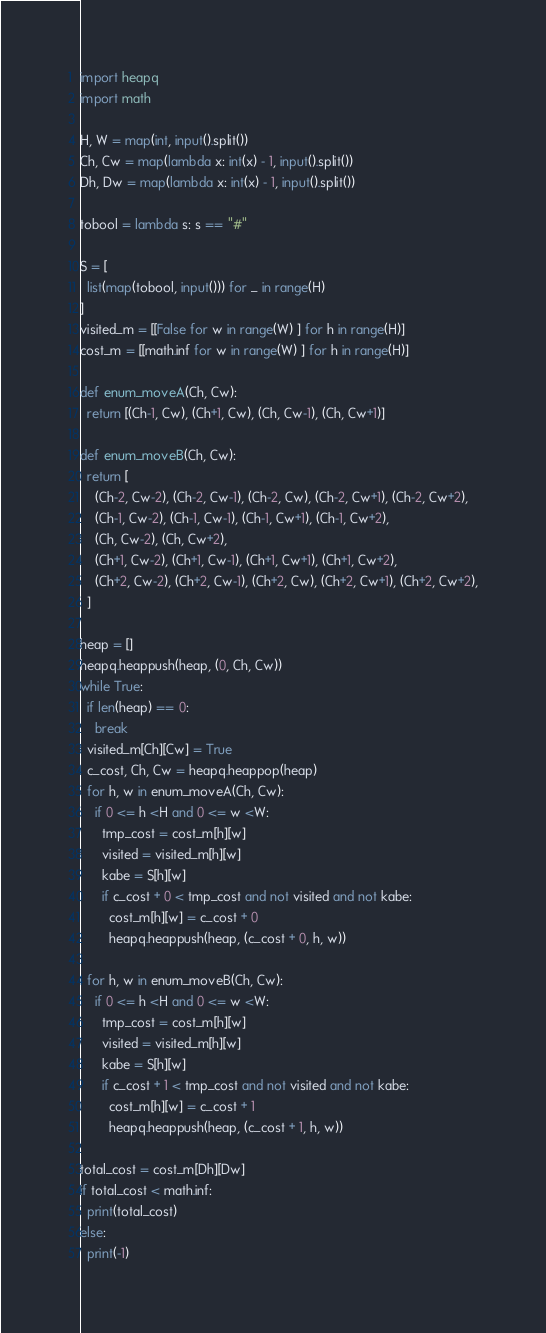<code> <loc_0><loc_0><loc_500><loc_500><_Python_>import heapq
import math

H, W = map(int, input().split())
Ch, Cw = map(lambda x: int(x) - 1, input().split())
Dh, Dw = map(lambda x: int(x) - 1, input().split())

tobool = lambda s: s == "#"

S = [
  list(map(tobool, input())) for _ in range(H)
]
visited_m = [[False for w in range(W) ] for h in range(H)]
cost_m = [[math.inf for w in range(W) ] for h in range(H)]

def enum_moveA(Ch, Cw):
  return [(Ch-1, Cw), (Ch+1, Cw), (Ch, Cw-1), (Ch, Cw+1)]

def enum_moveB(Ch, Cw):
  return [
    (Ch-2, Cw-2), (Ch-2, Cw-1), (Ch-2, Cw), (Ch-2, Cw+1), (Ch-2, Cw+2),
    (Ch-1, Cw-2), (Ch-1, Cw-1), (Ch-1, Cw+1), (Ch-1, Cw+2),
    (Ch, Cw-2), (Ch, Cw+2),
    (Ch+1, Cw-2), (Ch+1, Cw-1), (Ch+1, Cw+1), (Ch+1, Cw+2),
    (Ch+2, Cw-2), (Ch+2, Cw-1), (Ch+2, Cw), (Ch+2, Cw+1), (Ch+2, Cw+2),
  ]

heap = []
heapq.heappush(heap, (0, Ch, Cw))
while True:
  if len(heap) == 0:
    break
  visited_m[Ch][Cw] = True
  c_cost, Ch, Cw = heapq.heappop(heap)
  for h, w in enum_moveA(Ch, Cw):
    if 0 <= h <H and 0 <= w <W:
      tmp_cost = cost_m[h][w]
      visited = visited_m[h][w]
      kabe = S[h][w]
      if c_cost + 0 < tmp_cost and not visited and not kabe:
        cost_m[h][w] = c_cost + 0
        heapq.heappush(heap, (c_cost + 0, h, w))
        
  for h, w in enum_moveB(Ch, Cw):
    if 0 <= h <H and 0 <= w <W:
      tmp_cost = cost_m[h][w]
      visited = visited_m[h][w]
      kabe = S[h][w]
      if c_cost + 1 < tmp_cost and not visited and not kabe:
        cost_m[h][w] = c_cost + 1
        heapq.heappush(heap, (c_cost + 1, h, w))
    
total_cost = cost_m[Dh][Dw]
if total_cost < math.inf:
  print(total_cost)
else:
  print(-1)</code> 